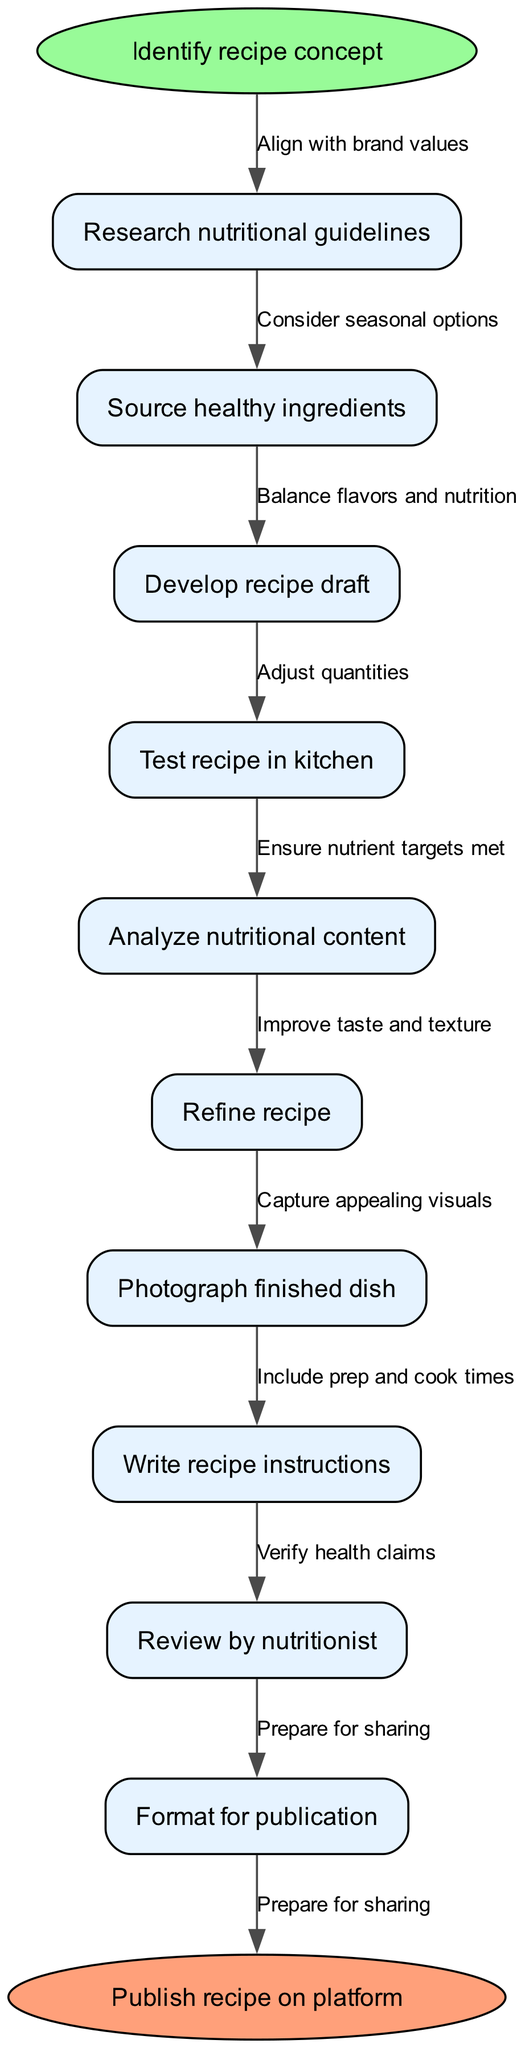What is the starting point of the recipe creation process? The starting point is explicitly marked in the diagram as "Identify recipe concept." It is the first element in the flow chart.
Answer: Identify recipe concept How many nodes are included in the recipe creation process? By counting the individual process nodes listed, there are a total of 9 nodes in the diagram representing steps in the recipe creation process.
Answer: 9 What is the last process before publication? The last node before the end of the flowchart is "Format for publication," indicating that formatting is the final step in the process.
Answer: Format for publication Which node is connected to "Research nutritional guidelines"? The node immediately following "Research nutritional guidelines" is "Source healthy ingredients." This shows the direct flow from researching to sourcing ingredients.
Answer: Source healthy ingredients What edge connects "Test recipe in kitchen" to the next node? The edge connecting "Test recipe in kitchen" to the next node is labeled "Adjust quantities," indicating this adjustment is made after testing the recipe.
Answer: Adjust quantities What is the function of the "Review by nutritionist" node? The purpose of the "Review by nutritionist" node is to ensure that the recipe meets health standards before it is published, indicating it is a quality assurance step.
Answer: Ensure nutrient targets met What connects "Analyze nutritional content" and "Refine recipe"? The connection labeled "Improve taste and texture" links these two nodes, suggesting that analyzing the nutritional content informs how the recipe can be refined for flavor and texture.
Answer: Improve taste and texture How does the process begin in relation to brand values? The first process node, "Research nutritional guidelines," is connected to the start node via the edge "Align with brand values," showing that the process begins with considering brand values.
Answer: Align with brand values What does the process end with? The end of the flowchart is marked by the phrase "Publish recipe on platform," indicating the final action taken after the entire process concludes.
Answer: Publish recipe on platform 